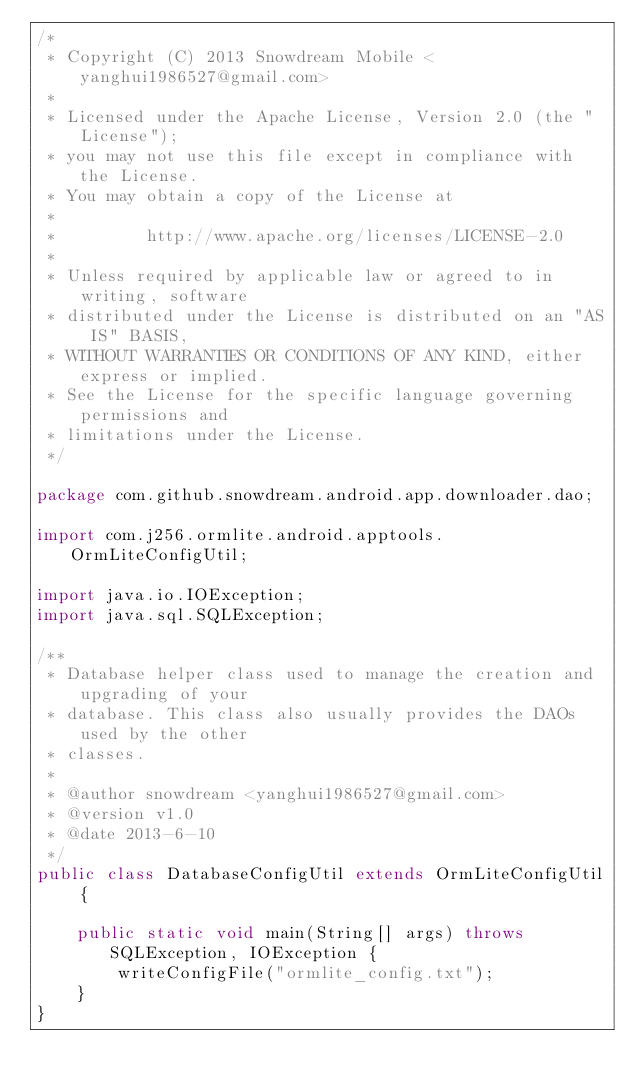Convert code to text. <code><loc_0><loc_0><loc_500><loc_500><_Java_>/*
 * Copyright (C) 2013 Snowdream Mobile <yanghui1986527@gmail.com>
 *
 * Licensed under the Apache License, Version 2.0 (the "License");
 * you may not use this file except in compliance with the License.
 * You may obtain a copy of the License at
 *
 *         http://www.apache.org/licenses/LICENSE-2.0
 *
 * Unless required by applicable law or agreed to in writing, software
 * distributed under the License is distributed on an "AS IS" BASIS,
 * WITHOUT WARRANTIES OR CONDITIONS OF ANY KIND, either express or implied.
 * See the License for the specific language governing permissions and
 * limitations under the License.
 */

package com.github.snowdream.android.app.downloader.dao;

import com.j256.ormlite.android.apptools.OrmLiteConfigUtil;

import java.io.IOException;
import java.sql.SQLException;

/**
 * Database helper class used to manage the creation and upgrading of your
 * database. This class also usually provides the DAOs used by the other
 * classes.
 *
 * @author snowdream <yanghui1986527@gmail.com>
 * @version v1.0
 * @date 2013-6-10
 */
public class DatabaseConfigUtil extends OrmLiteConfigUtil {

    public static void main(String[] args) throws SQLException, IOException {
        writeConfigFile("ormlite_config.txt");
    }
}
</code> 